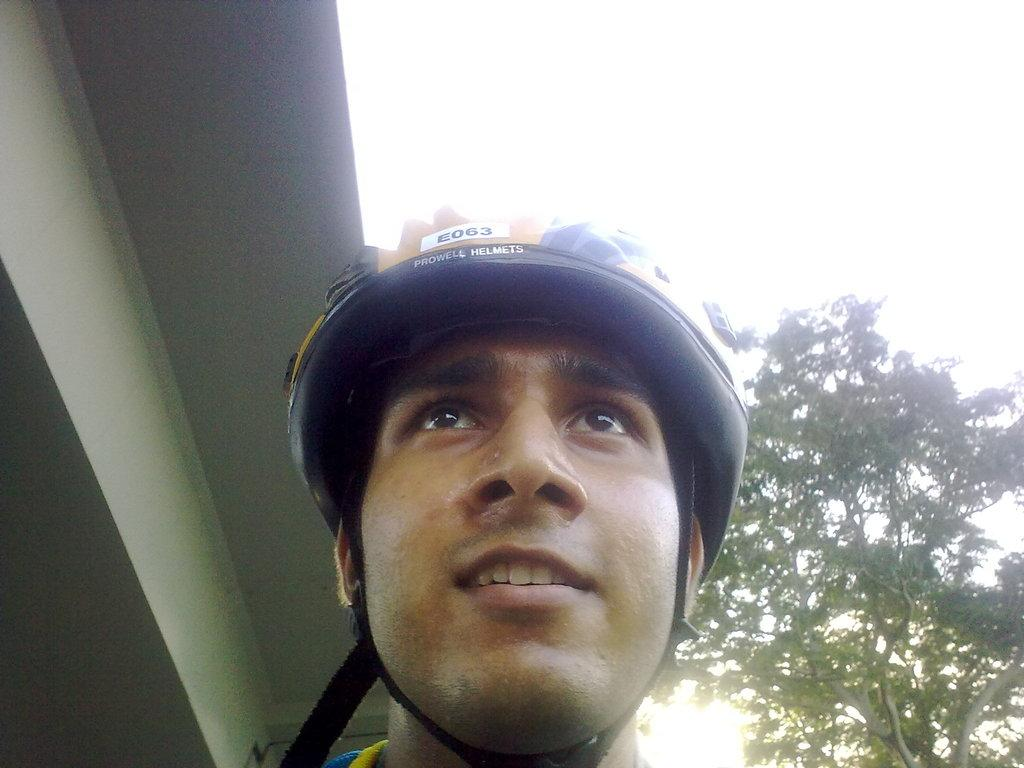What is the person in the image wearing on their head? The person in the image is wearing a helmet. What structure can be seen on the left side of the image? There is a roof on the left side of the image. What type of vegetation is on the right side of the image? There is a tree on the right side of the image. What is visible in the background of the image? The sky is visible in the image. What type of root can be seen growing from the helmet in the image? There is no root growing from the helmet in the image; the person is simply wearing a helmet. 